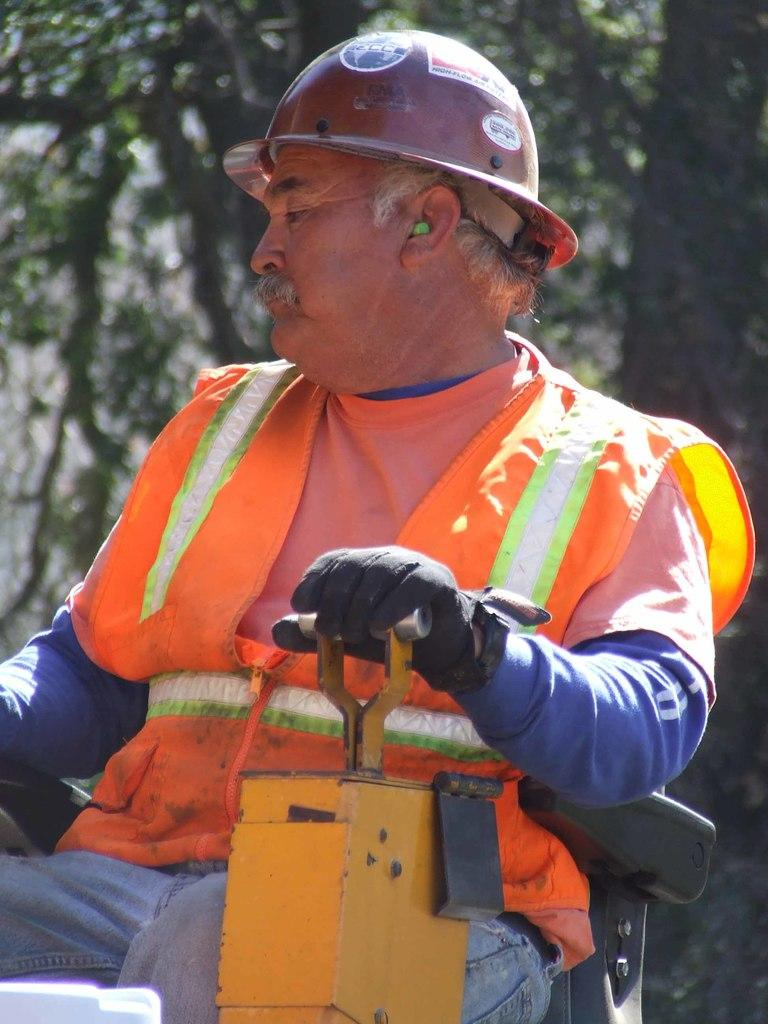Who or what is the main subject in the image? There is a person in the image. What is the person wearing? The person is wearing a helmet. What is the person doing in the image? The person is sitting. What is the person touching in the image? The person has one hand placed on a yellow object. What can be seen in the background of the image? There are trees in the background of the image. What type of park is visible in the image? There is no park visible in the image; it features a person sitting with a helmet and a yellow object. What achievements has the person in the image accomplished? There is no information about the person's achievements in the image. 